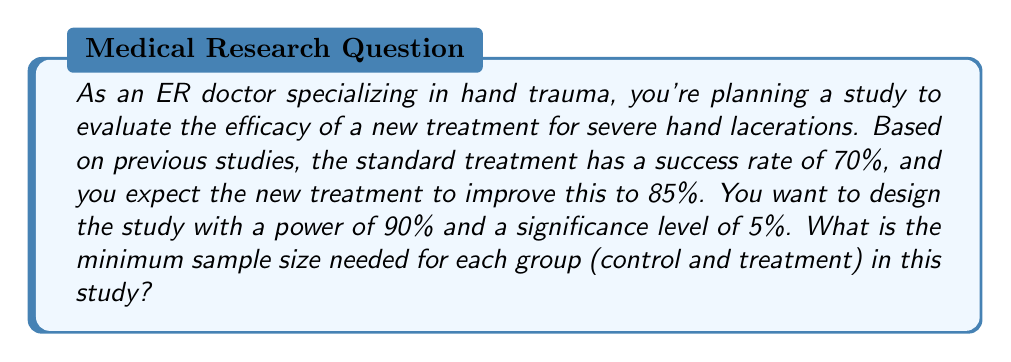Can you solve this math problem? To calculate the sample size, we'll use the formula for comparing two proportions:

$$n = \frac{(Z_\alpha + Z_\beta)^2 [p_1(1-p_1) + p_2(1-p_2)]}{(p_1 - p_2)^2}$$

Where:
$n$ = sample size per group
$Z_\alpha$ = Z-score for significance level (α)
$Z_\beta$ = Z-score for power (1-β)
$p_1$ = proportion in group 1 (standard treatment)
$p_2$ = proportion in group 2 (new treatment)

Step 1: Determine Z-scores
For α = 0.05 (two-tailed), $Z_\alpha = 1.96$
For power = 90%, $Z_\beta = 1.28$

Step 2: Insert known values
$p_1 = 0.70$ (standard treatment success rate)
$p_2 = 0.85$ (expected new treatment success rate)

Step 3: Calculate
$$n = \frac{(1.96 + 1.28)^2 [0.70(1-0.70) + 0.85(1-0.85)]}{(0.70 - 0.85)^2}$$

$$n = \frac{10.5156 [0.21 + 0.1275]}{0.0225}$$

$$n = \frac{10.5156 * 0.3375}{0.0225} = 157.73$$

Step 4: Round up to the nearest whole number
$n ≈ 158$

Therefore, the minimum sample size needed for each group is 158 patients.
Answer: 158 patients per group 